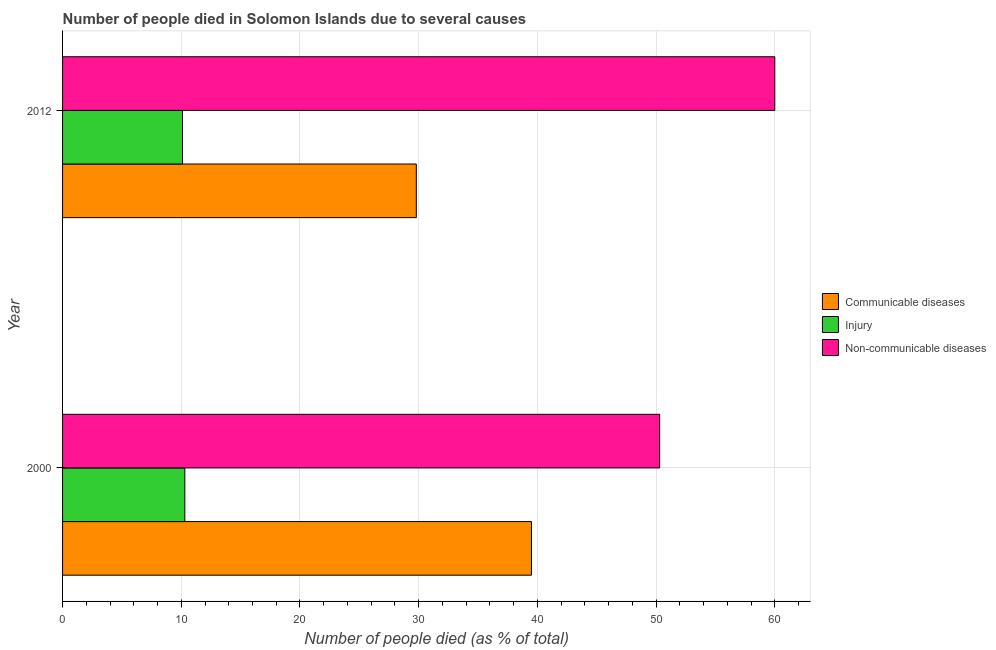How many different coloured bars are there?
Keep it short and to the point. 3. How many groups of bars are there?
Your answer should be compact. 2. Are the number of bars on each tick of the Y-axis equal?
Make the answer very short. Yes. How many bars are there on the 1st tick from the bottom?
Make the answer very short. 3. What is the number of people who dies of non-communicable diseases in 2000?
Your response must be concise. 50.3. Across all years, what is the maximum number of people who dies of non-communicable diseases?
Provide a succinct answer. 60. Across all years, what is the minimum number of people who dies of non-communicable diseases?
Provide a short and direct response. 50.3. In which year was the number of people who dies of non-communicable diseases minimum?
Make the answer very short. 2000. What is the total number of people who died of communicable diseases in the graph?
Provide a short and direct response. 69.3. What is the difference between the number of people who died of communicable diseases in 2000 and the number of people who dies of non-communicable diseases in 2012?
Make the answer very short. -20.5. What is the average number of people who died of communicable diseases per year?
Make the answer very short. 34.65. In the year 2012, what is the difference between the number of people who dies of non-communicable diseases and number of people who died of injury?
Ensure brevity in your answer.  49.9. In how many years, is the number of people who dies of non-communicable diseases greater than 60 %?
Give a very brief answer. 0. What is the ratio of the number of people who died of injury in 2000 to that in 2012?
Ensure brevity in your answer.  1.02. In how many years, is the number of people who died of injury greater than the average number of people who died of injury taken over all years?
Your response must be concise. 1. What does the 1st bar from the top in 2012 represents?
Your answer should be compact. Non-communicable diseases. What does the 3rd bar from the bottom in 2000 represents?
Ensure brevity in your answer.  Non-communicable diseases. Is it the case that in every year, the sum of the number of people who died of communicable diseases and number of people who died of injury is greater than the number of people who dies of non-communicable diseases?
Ensure brevity in your answer.  No. Are all the bars in the graph horizontal?
Offer a very short reply. Yes. How many years are there in the graph?
Keep it short and to the point. 2. What is the difference between two consecutive major ticks on the X-axis?
Your answer should be very brief. 10. Are the values on the major ticks of X-axis written in scientific E-notation?
Your answer should be very brief. No. Does the graph contain any zero values?
Give a very brief answer. No. How many legend labels are there?
Your answer should be compact. 3. What is the title of the graph?
Provide a short and direct response. Number of people died in Solomon Islands due to several causes. Does "Czech Republic" appear as one of the legend labels in the graph?
Your answer should be compact. No. What is the label or title of the X-axis?
Provide a succinct answer. Number of people died (as % of total). What is the label or title of the Y-axis?
Your response must be concise. Year. What is the Number of people died (as % of total) of Communicable diseases in 2000?
Your response must be concise. 39.5. What is the Number of people died (as % of total) of Non-communicable diseases in 2000?
Offer a very short reply. 50.3. What is the Number of people died (as % of total) of Communicable diseases in 2012?
Offer a very short reply. 29.8. What is the Number of people died (as % of total) in Injury in 2012?
Offer a very short reply. 10.1. What is the Number of people died (as % of total) of Non-communicable diseases in 2012?
Provide a succinct answer. 60. Across all years, what is the maximum Number of people died (as % of total) of Communicable diseases?
Provide a succinct answer. 39.5. Across all years, what is the maximum Number of people died (as % of total) in Injury?
Make the answer very short. 10.3. Across all years, what is the minimum Number of people died (as % of total) in Communicable diseases?
Offer a very short reply. 29.8. Across all years, what is the minimum Number of people died (as % of total) of Injury?
Provide a short and direct response. 10.1. Across all years, what is the minimum Number of people died (as % of total) of Non-communicable diseases?
Ensure brevity in your answer.  50.3. What is the total Number of people died (as % of total) of Communicable diseases in the graph?
Provide a short and direct response. 69.3. What is the total Number of people died (as % of total) in Injury in the graph?
Ensure brevity in your answer.  20.4. What is the total Number of people died (as % of total) in Non-communicable diseases in the graph?
Give a very brief answer. 110.3. What is the difference between the Number of people died (as % of total) in Communicable diseases in 2000 and that in 2012?
Your answer should be compact. 9.7. What is the difference between the Number of people died (as % of total) of Injury in 2000 and that in 2012?
Make the answer very short. 0.2. What is the difference between the Number of people died (as % of total) of Communicable diseases in 2000 and the Number of people died (as % of total) of Injury in 2012?
Your response must be concise. 29.4. What is the difference between the Number of people died (as % of total) in Communicable diseases in 2000 and the Number of people died (as % of total) in Non-communicable diseases in 2012?
Provide a succinct answer. -20.5. What is the difference between the Number of people died (as % of total) in Injury in 2000 and the Number of people died (as % of total) in Non-communicable diseases in 2012?
Keep it short and to the point. -49.7. What is the average Number of people died (as % of total) of Communicable diseases per year?
Your response must be concise. 34.65. What is the average Number of people died (as % of total) of Non-communicable diseases per year?
Offer a terse response. 55.15. In the year 2000, what is the difference between the Number of people died (as % of total) of Communicable diseases and Number of people died (as % of total) of Injury?
Ensure brevity in your answer.  29.2. In the year 2000, what is the difference between the Number of people died (as % of total) in Communicable diseases and Number of people died (as % of total) in Non-communicable diseases?
Make the answer very short. -10.8. In the year 2012, what is the difference between the Number of people died (as % of total) of Communicable diseases and Number of people died (as % of total) of Injury?
Make the answer very short. 19.7. In the year 2012, what is the difference between the Number of people died (as % of total) in Communicable diseases and Number of people died (as % of total) in Non-communicable diseases?
Offer a very short reply. -30.2. In the year 2012, what is the difference between the Number of people died (as % of total) of Injury and Number of people died (as % of total) of Non-communicable diseases?
Your response must be concise. -49.9. What is the ratio of the Number of people died (as % of total) of Communicable diseases in 2000 to that in 2012?
Offer a very short reply. 1.33. What is the ratio of the Number of people died (as % of total) of Injury in 2000 to that in 2012?
Offer a terse response. 1.02. What is the ratio of the Number of people died (as % of total) of Non-communicable diseases in 2000 to that in 2012?
Your response must be concise. 0.84. What is the difference between the highest and the second highest Number of people died (as % of total) of Injury?
Your answer should be very brief. 0.2. What is the difference between the highest and the lowest Number of people died (as % of total) of Communicable diseases?
Your answer should be compact. 9.7. What is the difference between the highest and the lowest Number of people died (as % of total) in Injury?
Your answer should be very brief. 0.2. What is the difference between the highest and the lowest Number of people died (as % of total) in Non-communicable diseases?
Give a very brief answer. 9.7. 